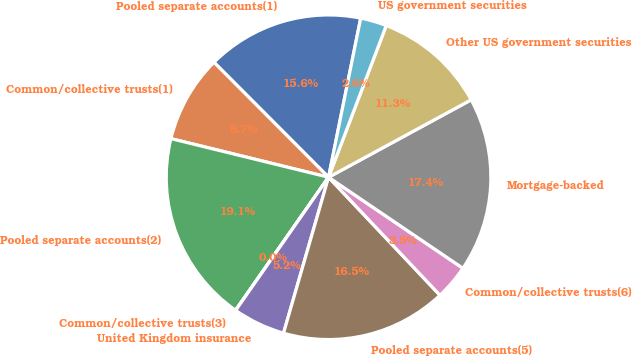Convert chart to OTSL. <chart><loc_0><loc_0><loc_500><loc_500><pie_chart><fcel>Pooled separate accounts(1)<fcel>Common/collective trusts(1)<fcel>Pooled separate accounts(2)<fcel>Common/collective trusts(3)<fcel>United Kingdom insurance<fcel>Pooled separate accounts(5)<fcel>Common/collective trusts(6)<fcel>Mortgage-backed<fcel>Other US government securities<fcel>US government securities<nl><fcel>15.65%<fcel>8.7%<fcel>19.12%<fcel>0.01%<fcel>5.22%<fcel>16.52%<fcel>3.48%<fcel>17.39%<fcel>11.3%<fcel>2.61%<nl></chart> 